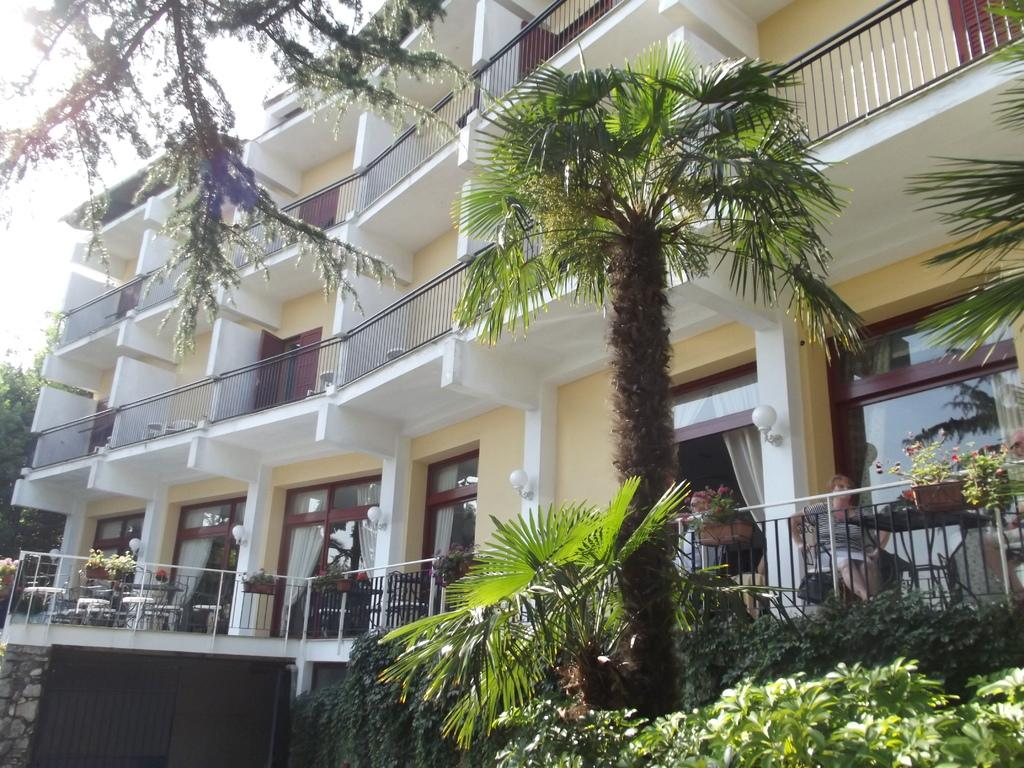Who or what can be seen in the image? There are people in the image. What type of natural elements are present in the image? There are plants, flowers, and trees in the image. Are there any man-made structures visible in the image? Yes, there is a building in the image. What might be used for safety or support in the image? There are railings in the image. What can be seen in the background of the image? The sky is visible in the background of the image. What type of cat can be seen performing on stage in the image? There is no cat or stage present in the image; it features people, plants, flowers, trees, a building, railings, and the sky. 